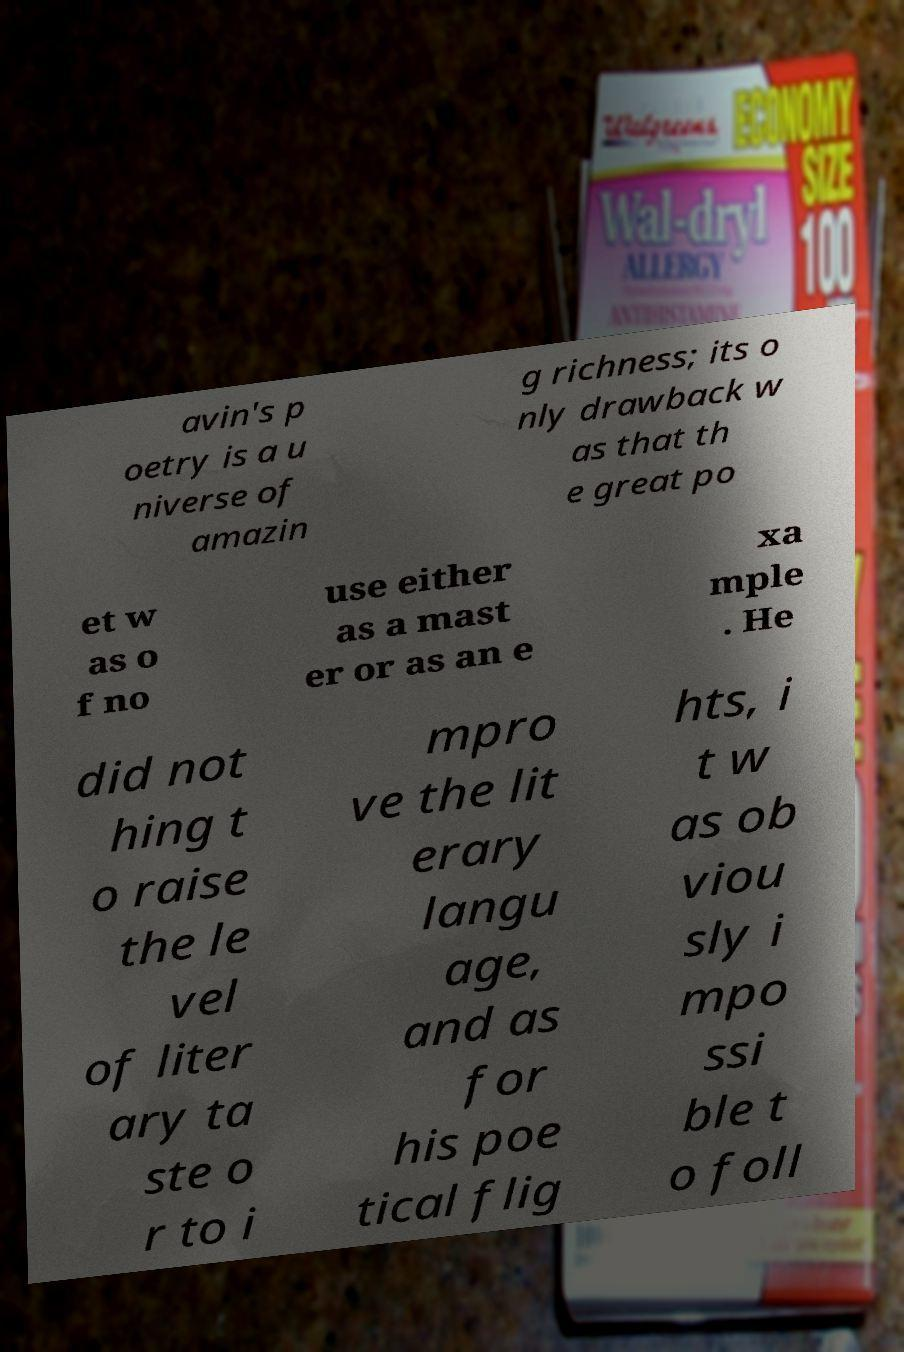Can you read and provide the text displayed in the image?This photo seems to have some interesting text. Can you extract and type it out for me? avin's p oetry is a u niverse of amazin g richness; its o nly drawback w as that th e great po et w as o f no use either as a mast er or as an e xa mple . He did not hing t o raise the le vel of liter ary ta ste o r to i mpro ve the lit erary langu age, and as for his poe tical flig hts, i t w as ob viou sly i mpo ssi ble t o foll 